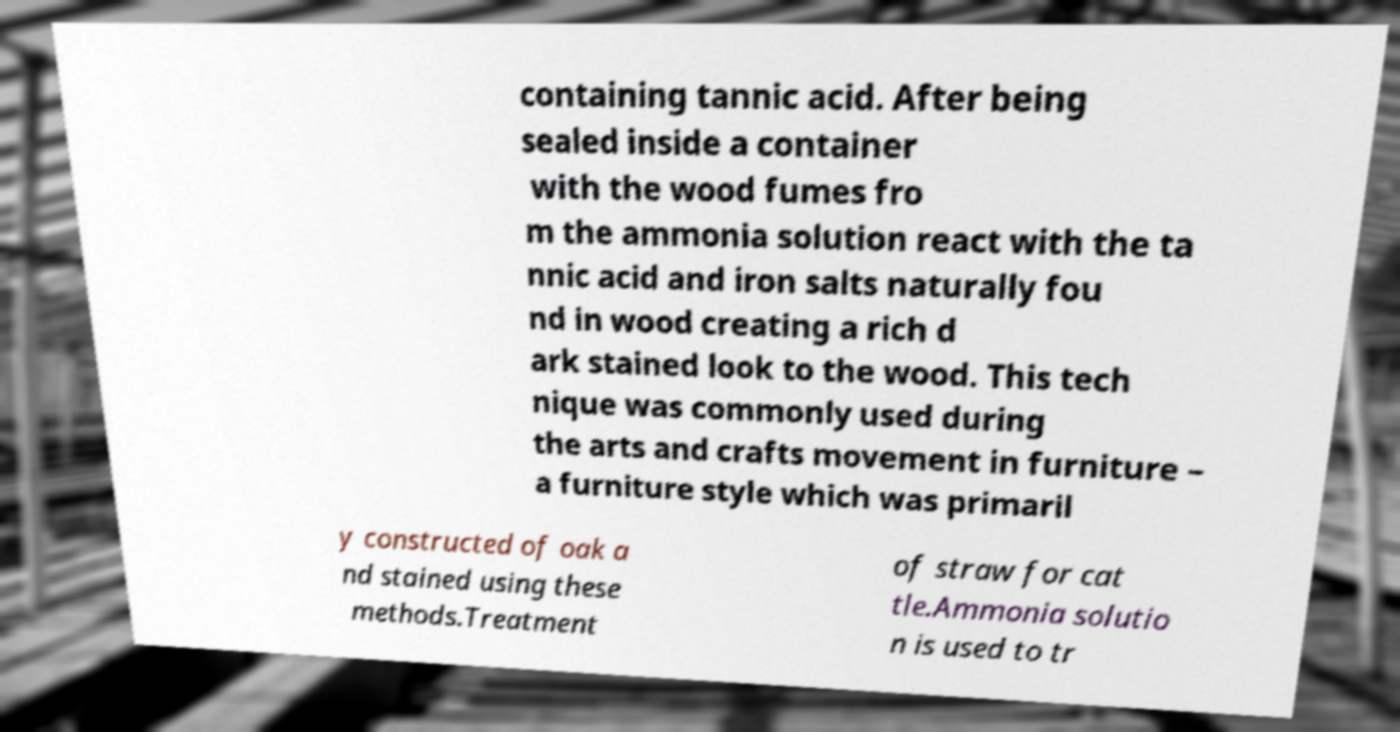Please read and relay the text visible in this image. What does it say? containing tannic acid. After being sealed inside a container with the wood fumes fro m the ammonia solution react with the ta nnic acid and iron salts naturally fou nd in wood creating a rich d ark stained look to the wood. This tech nique was commonly used during the arts and crafts movement in furniture – a furniture style which was primaril y constructed of oak a nd stained using these methods.Treatment of straw for cat tle.Ammonia solutio n is used to tr 